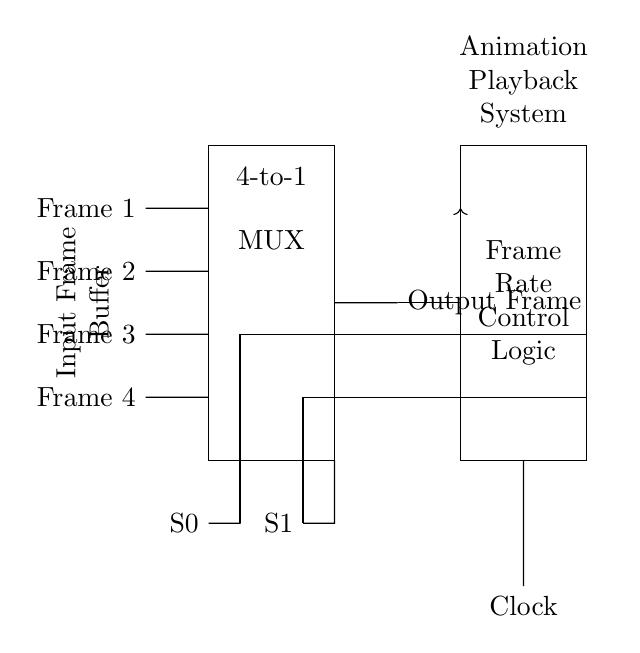What type of multiplexer is used in this circuit? The circuit uses a 4-to-1 multiplexer, which allows for selecting one of four input frames based on the selection signals.
Answer: 4-to-1 How many input signals are connected to the multiplexer? There are four input signals labeled Frame 1, Frame 2, Frame 3, and Frame 4 connected to the multiplexer.
Answer: Four What is the purpose of the selector inputs S0 and S1? The selector inputs S0 and S1 determine which of the four input frames will be passed to the output of the multiplexer.
Answer: Selection What does the feedback loop from the output to the Frame Rate Control Logic indicate? The feedback loop suggests that the output frame can be used to adjust or control the frame rate in the animation playback system, incorporating the actual output in the control logic.
Answer: Control What does the rectangled component labeled "Frame Rate Control Logic" represent? This component represents the logic that controls the frames being outputted based on a clock signal, adjusting the playback rate accordingly.
Answer: Logic How is the output frame indicated in the diagram? The output frame is indicated by an arrow leading from the multiplexer to the right, labeled "Output Frame," showing the result of the selected input frame.
Answer: Output Frame What role does the clock signal play in the circuit? The clock signal synchronizes the operation of the Frame Rate Control Logic and determines when the input frames are evaluated and outputted.
Answer: Synchronization 